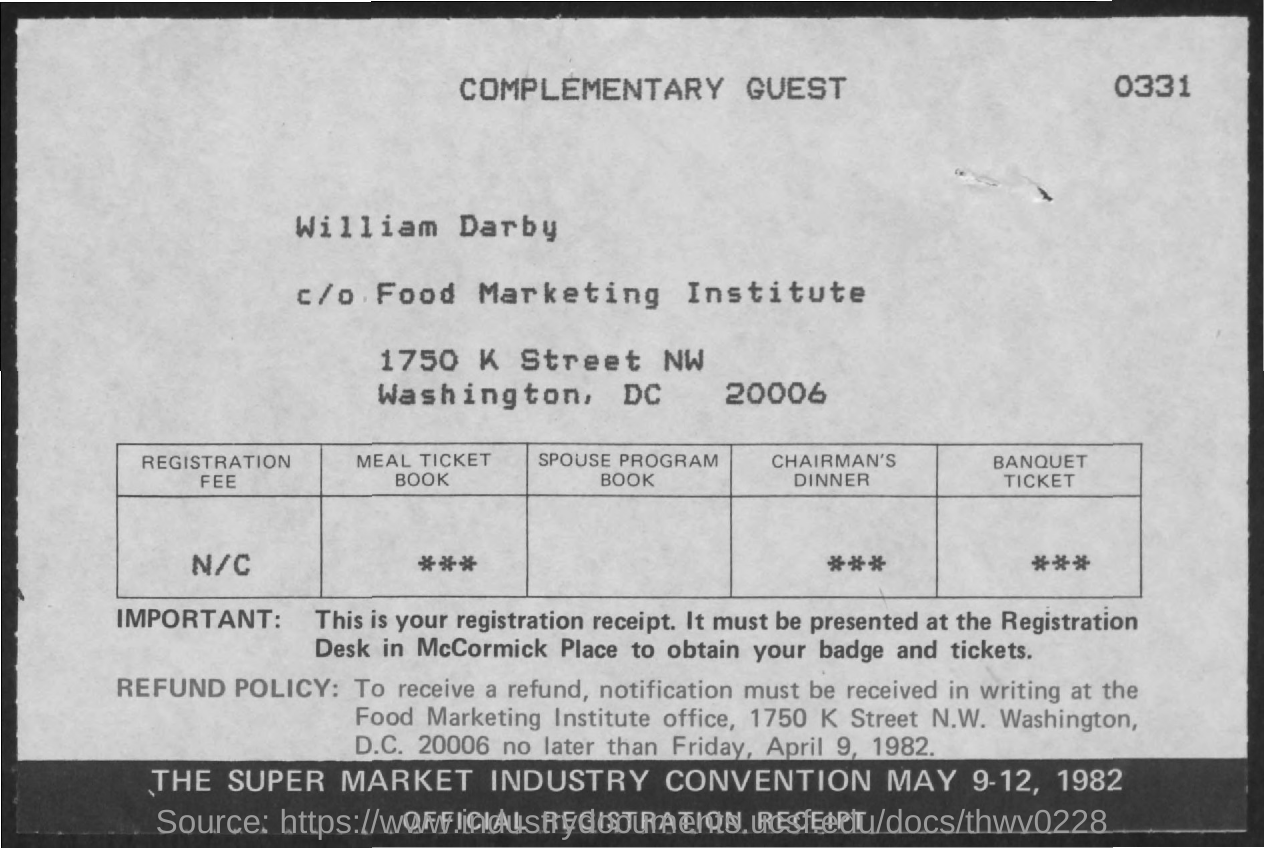To receive the refund notification must be received no later than when?
Offer a terse response. Friday, April 9, 1982. 